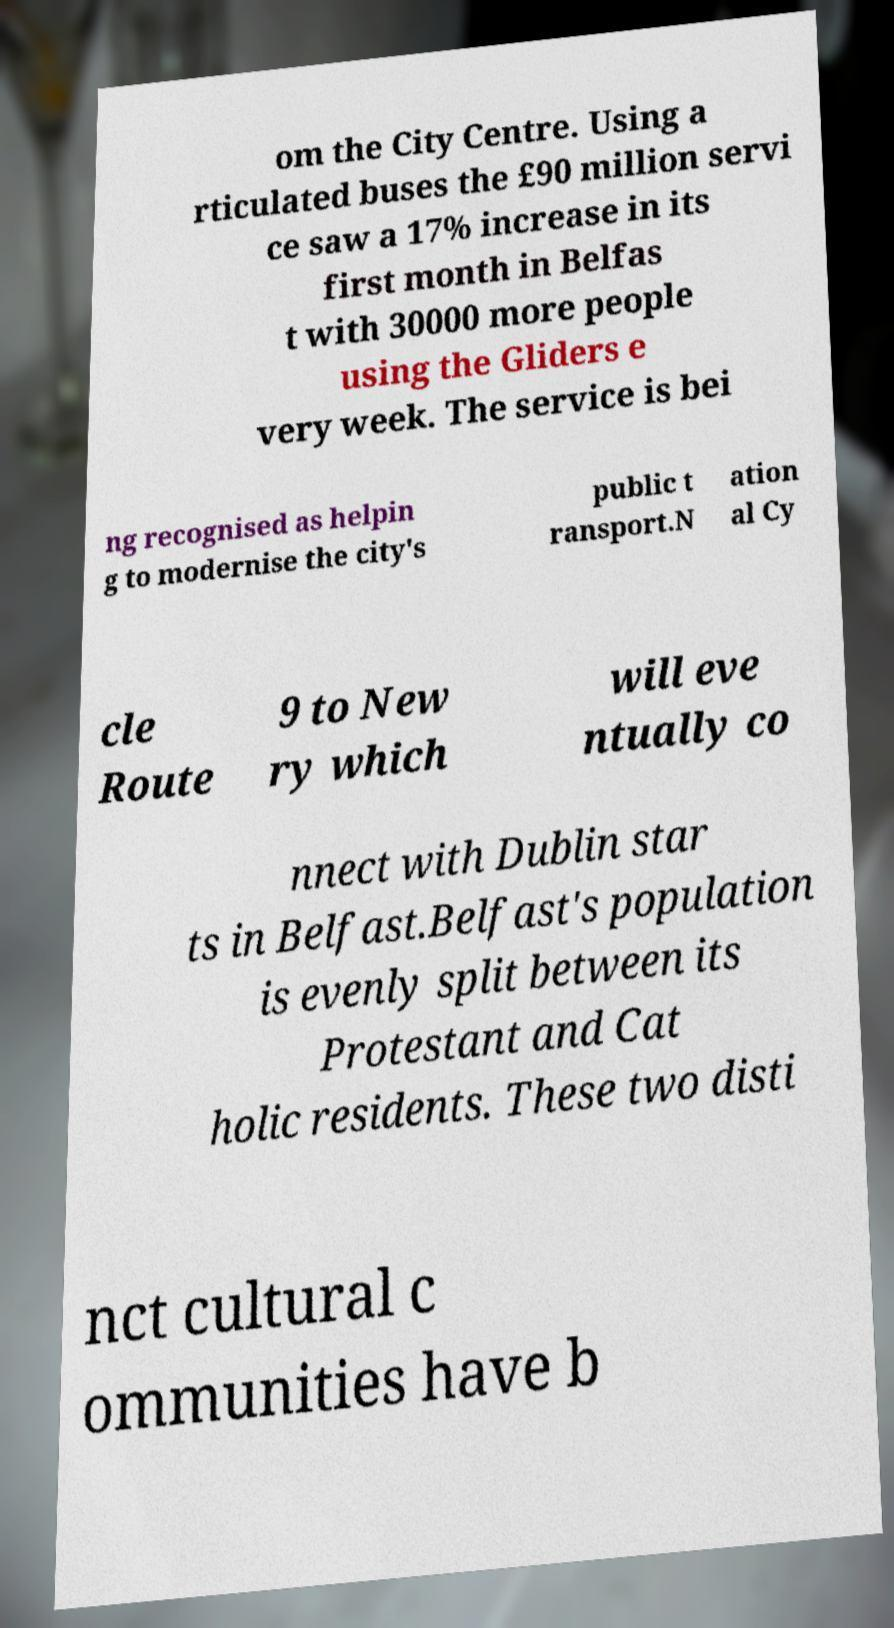I need the written content from this picture converted into text. Can you do that? om the City Centre. Using a rticulated buses the £90 million servi ce saw a 17% increase in its first month in Belfas t with 30000 more people using the Gliders e very week. The service is bei ng recognised as helpin g to modernise the city's public t ransport.N ation al Cy cle Route 9 to New ry which will eve ntually co nnect with Dublin star ts in Belfast.Belfast's population is evenly split between its Protestant and Cat holic residents. These two disti nct cultural c ommunities have b 